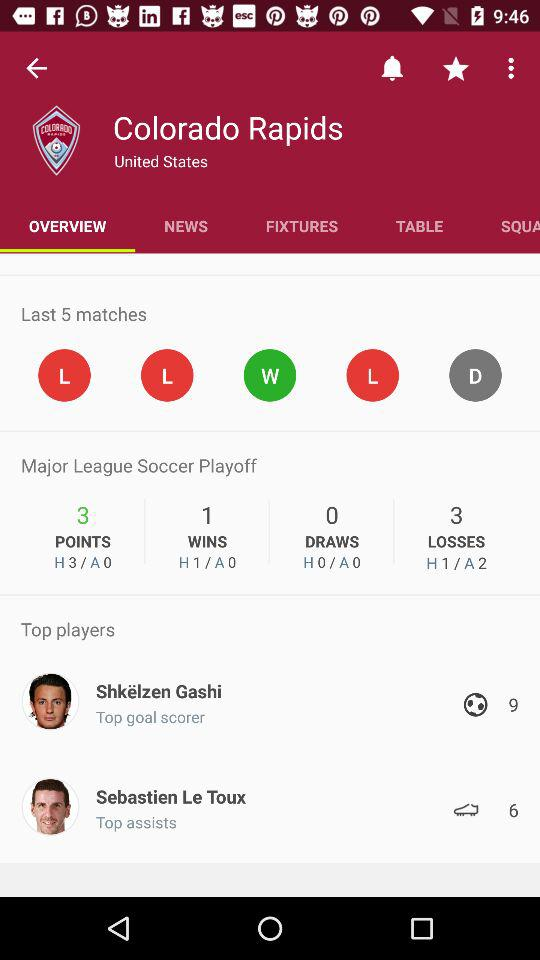How many more points does Colorado Rapids have than 0?
Answer the question using a single word or phrase. 3 